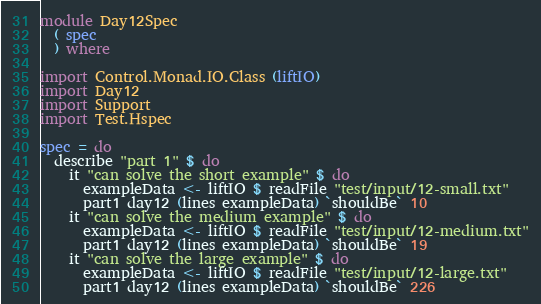Convert code to text. <code><loc_0><loc_0><loc_500><loc_500><_Haskell_>module Day12Spec
  ( spec
  ) where

import Control.Monad.IO.Class (liftIO)
import Day12
import Support
import Test.Hspec

spec = do
  describe "part 1" $ do
    it "can solve the short example" $ do
      exampleData <- liftIO $ readFile "test/input/12-small.txt"
      part1 day12 (lines exampleData) `shouldBe` 10
    it "can solve the medium example" $ do
      exampleData <- liftIO $ readFile "test/input/12-medium.txt"
      part1 day12 (lines exampleData) `shouldBe` 19
    it "can solve the large example" $ do
      exampleData <- liftIO $ readFile "test/input/12-large.txt"
      part1 day12 (lines exampleData) `shouldBe` 226</code> 